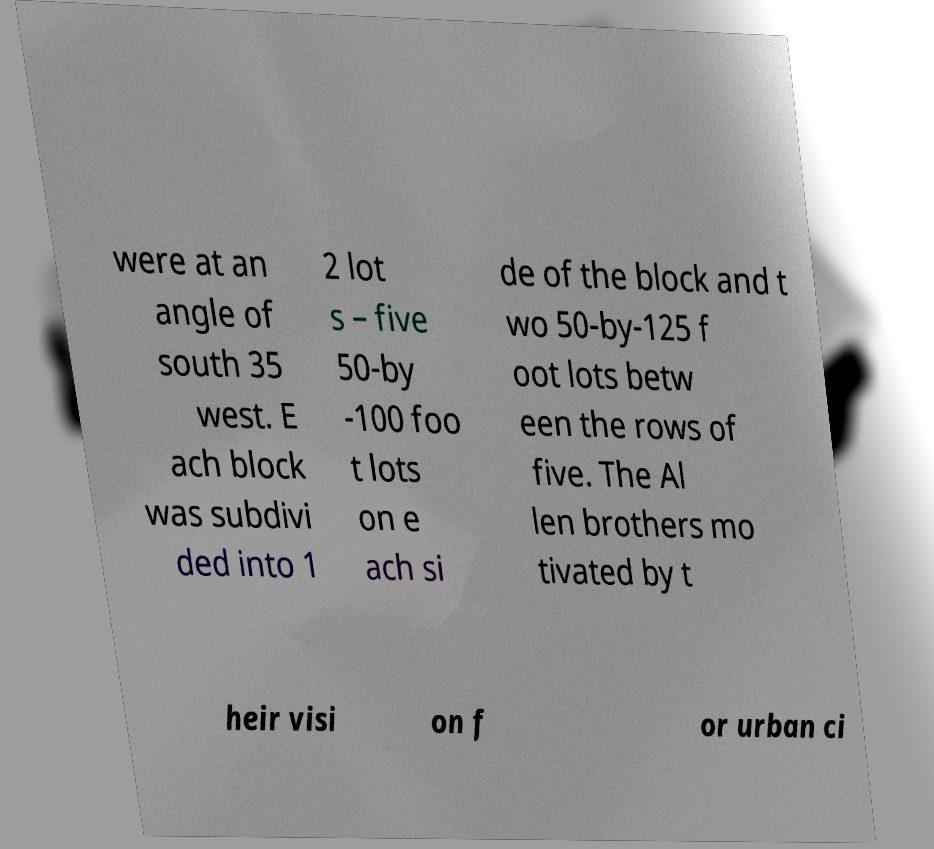There's text embedded in this image that I need extracted. Can you transcribe it verbatim? were at an angle of south 35 west. E ach block was subdivi ded into 1 2 lot s – five 50-by -100 foo t lots on e ach si de of the block and t wo 50-by-125 f oot lots betw een the rows of five. The Al len brothers mo tivated by t heir visi on f or urban ci 